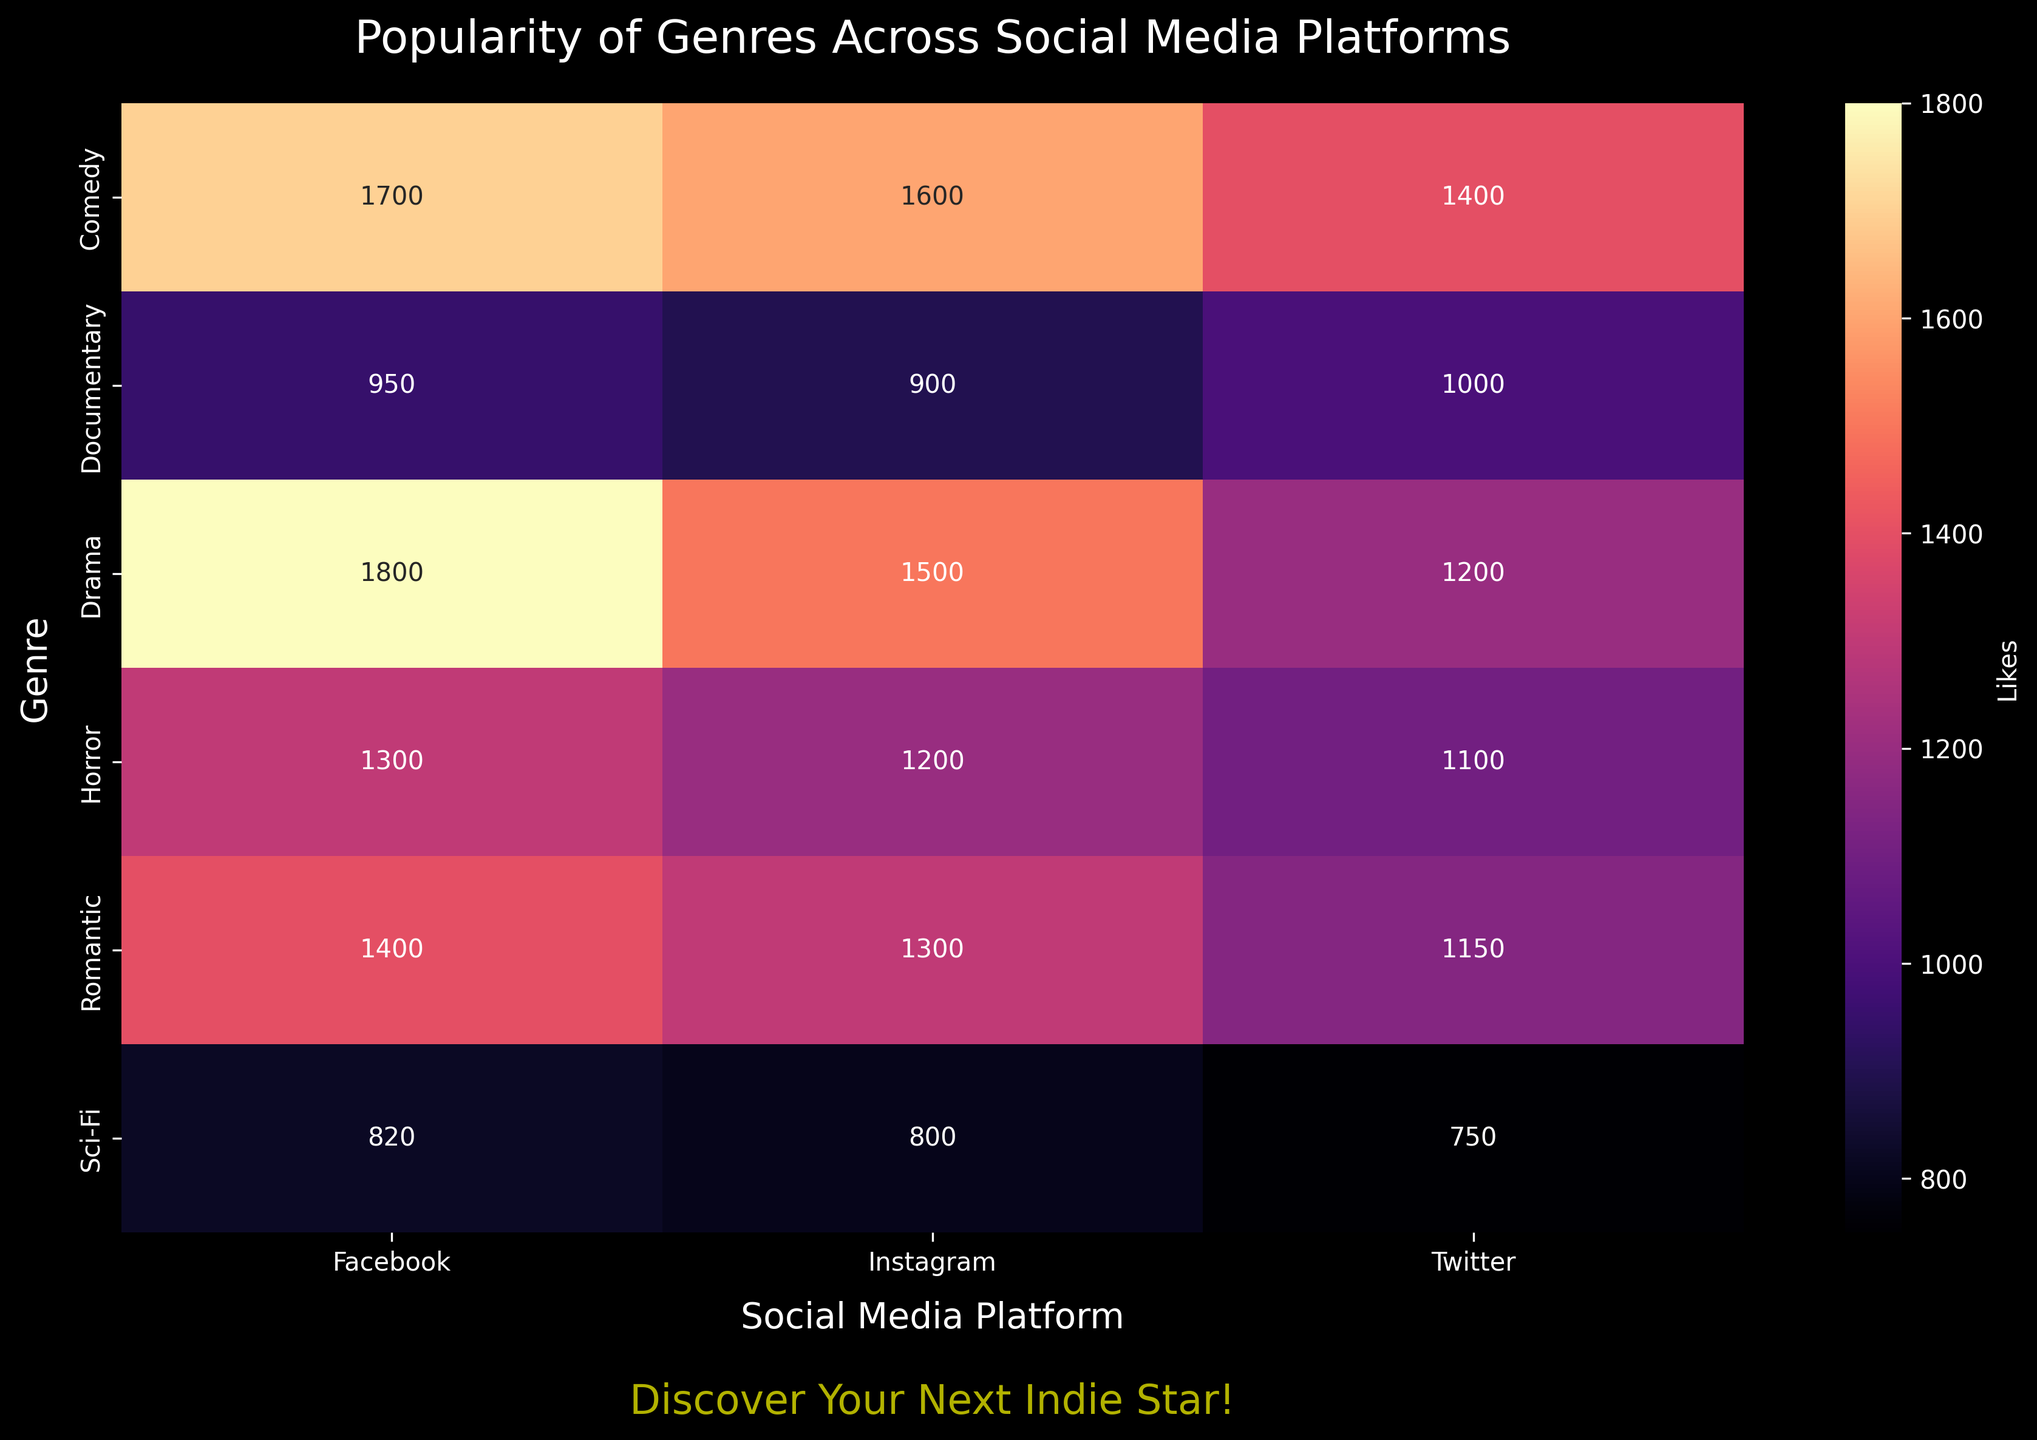What genre has the highest number of likes on Instagram? Look at the Instagram column and identify the genre with the highest value. Comedy has the highest with 1600 likes.
Answer: Comedy Which platform has the most likes for the Drama genre? Look at the row for Drama and find the highest value across the platform columns. Drama has the most likes on Facebook with 1800.
Answer: Facebook How many likes does the Horror genre have on all platforms combined? Sum the values for Horror across Instagram, Twitter, and Facebook: 1200 + 1100 + 1300 = 3600
Answer: 3600 Compare the total likes for Sci-Fi and Romantic genres. Which one is higher? Sum the likes for each genre across platforms. Sci-Fi: 800 + 750 + 820 = 2370, Romantic: 1300 + 1150 + 1400 = 3850. Romantic has more likes.
Answer: Romantic On which social media platform is the Documentary genre least popular based on likes? Look at the column values for Documentary and identify the lowest number. The Documentary genre has the least likes on Instagram with 900.
Answer: Instagram What is the average number of likes for Comedy across all platforms? Calculate the average by summing likes for Comedy and dividing by the number of platforms: (1600 + 1400 + 1700) / 3 = 1566.67.
Answer: 1566.67 Which genre has the lowest engagement on Twitter, considering only the likes? Look at the Twitter column and identify the lowest value. Sci-Fi has the lowest likes on Twitter with 750.
Answer: Sci-Fi What is the difference in likes between the most and least popular genres on Facebook? Identify the maximum and minimum likes for Facebook and subtract the minimum from the maximum: 1800 (Drama) - 820 (Sci-Fi) = 980.
Answer: 980 Which platform has a more even distribution of likes across all genres? Evaluate the variance of likes per platform. Twitter seems to have a more even distribution compared to Instagram and Facebook.
Answer: Twitter Are there any genres where the number of likes is consistently higher on every platform? Compare the number of likes across all genres and platforms to see if one genre always has higher values. Comedy has the highest or relatively high likes on all platforms.
Answer: Comedy 